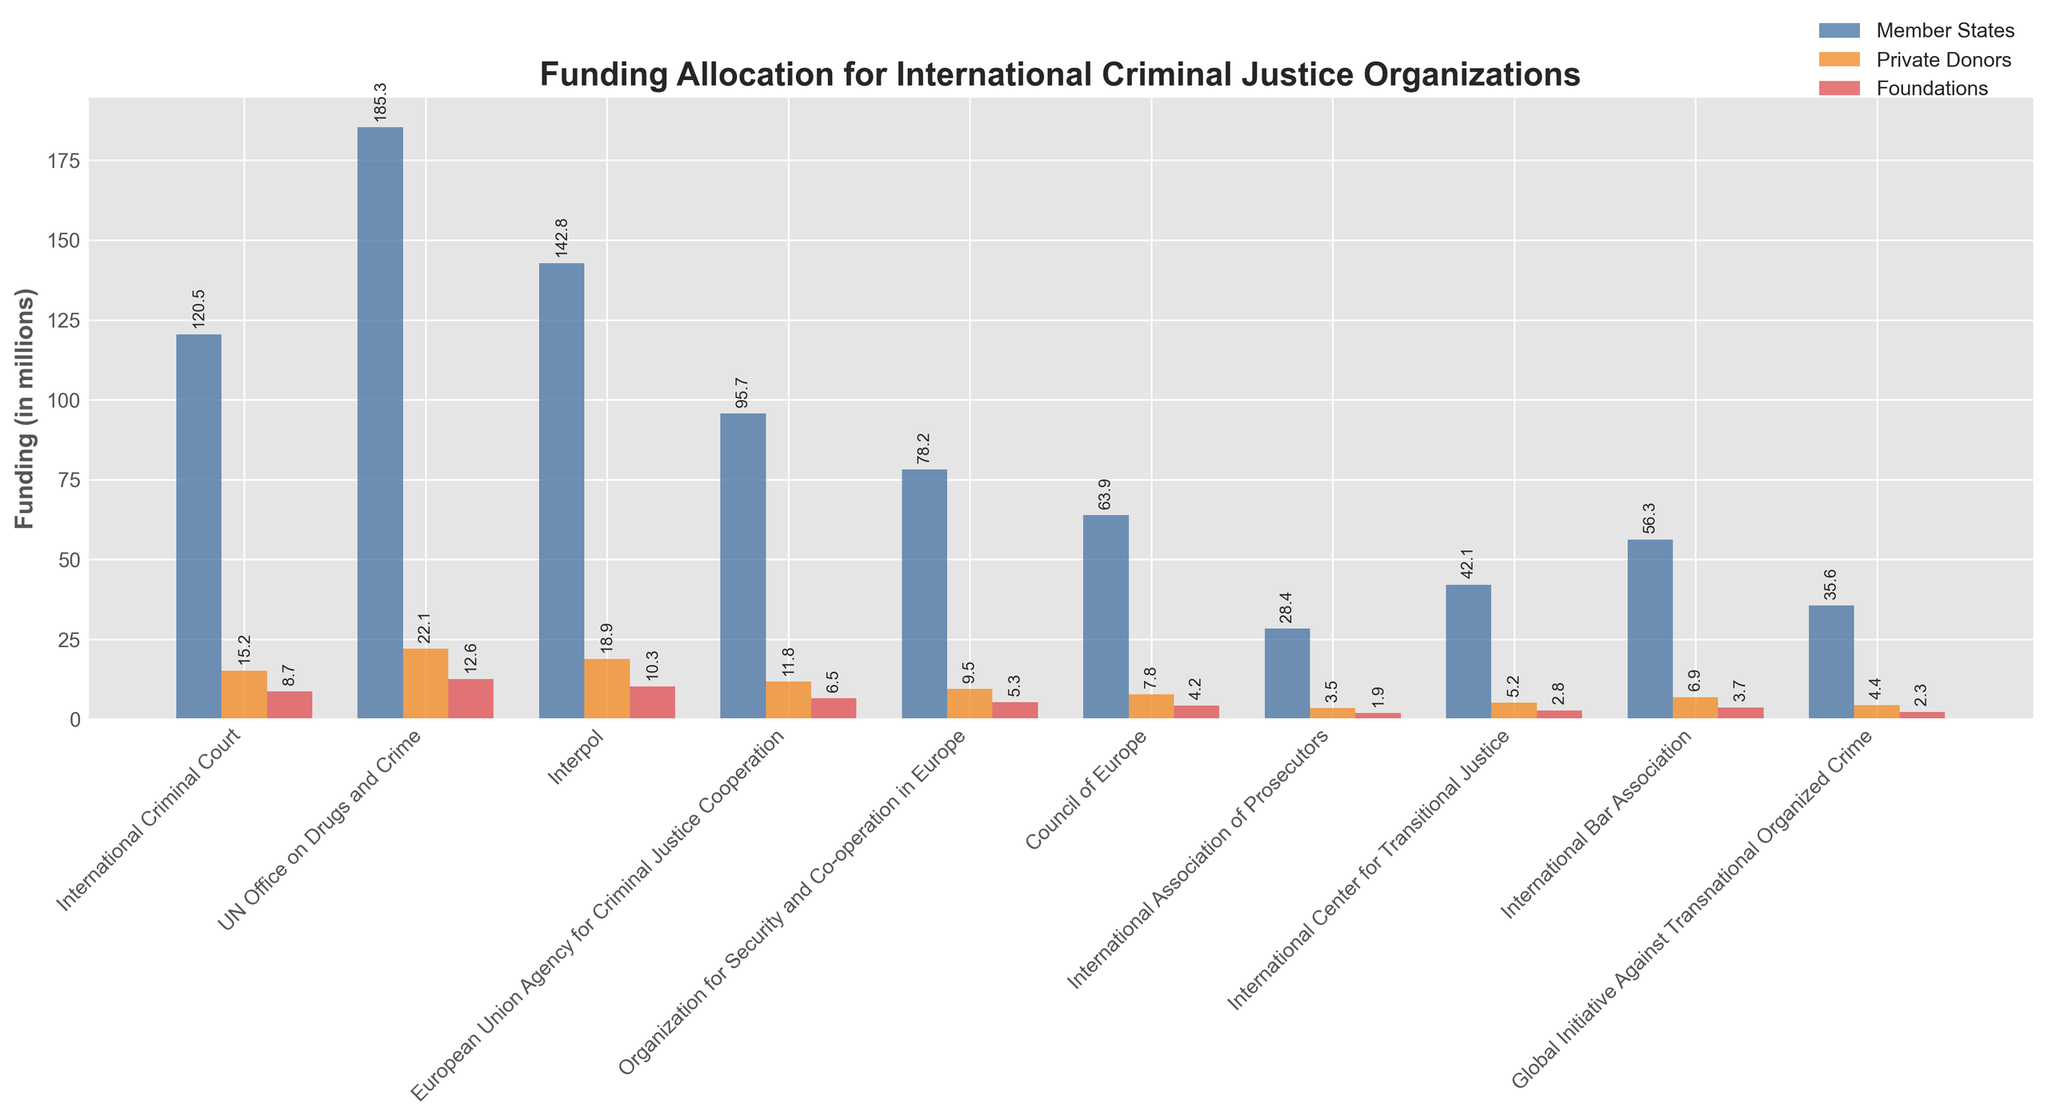Which organization receives the most funding from member states? Look at the height of the bars representing member states' funding for all organizations. The bar for the UN Office on Drugs and Crime is the highest for member states.
Answer: UN Office on Drugs and Crime Which organization receives the least funding from private donors? Look at the height of the bars representing private donors' funding for all organizations. The bar for the International Association of Prosecutors is the shortest for private donors.
Answer: International Association of Prosecutors What is the total funding for the International Criminal Court from all sources? Sum the heights of the bars for member states, private donors, and foundations for the International Criminal Court. The values are 120.5, 15.2, and 8.7.
Answer: 144.4 How does the funding from foundations for Interpol compare to that for the International Bar Association? Compare the heights of the bars for foundations' funding for Interpol and the International Bar Association. Interpol receives 10.3, while the International Bar Association receives 3.7.
Answer: Interpol receives more Which organization receives more funding from private donors: the Council of Europe or the Global Initiative Against Transnational Organized Crime? Compare the heights of the bars for private donors' funding for the Council of Europe and the Global Initiative Against Transnational Organized Crime. The Council of Europe receives 7.8, while the Global Initiative Against Transnational Organized Crime receives 4.4.
Answer: Council of Europe What is the average funding from foundations for all organizations? Sum the values of funding from foundations for all organizations, then divide by the number of organizations. The total is 48.3 (8.7+12.6+10.3+6.5+5.3+4.2+1.9+2.8+3.7+2.3), and there are 10 organizations. 48.3 / 10 = 4.83
Answer: 4.83 Which organizations receive more funding from private donors than from foundations? Look at the relative heights of the bars for private donors and foundations for each organization. The organizations where the private donors' bar is higher than the foundations' bar are: International Criminal Court, UN Office on Drugs and Crime, Interpol, European Union Agency for Criminal Justice Cooperation, Organization for Security and Co-operation in Europe, Council of Europe, International Association of Prosecutors, International Center for Transitional Justice, International Bar Association, and Global Initiative Against Transnational Organized Crime.
Answer: All listed organizations Which source contributes the second highest funding to the UN Office on Drugs and Crime? Compare the heights of the bars for member states, private donors, and foundations for the UN Office on Drugs and Crime. The highest is member states (185.3), and the second highest is private donors (22.1).
Answer: Private donors What is the difference in funding from member states between Interpol and the International Bar Association? Subtract the funding from member states for the International Bar Association from that for Interpol. The values are 142.8 for Interpol and 56.3 for the International Bar Association. 142.8 - 56.3 = 86.5
Answer: 86.5 